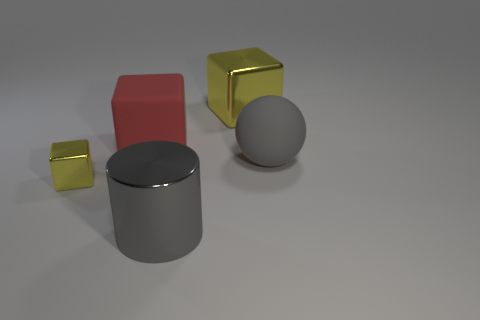There is a matte thing that is left of the big rubber sphere; is it the same shape as the small yellow metallic thing? The matte object to the left of the large rubber sphere is cylindrical, while the small yellow metallic item is a cube, thus they are not the same shape. 